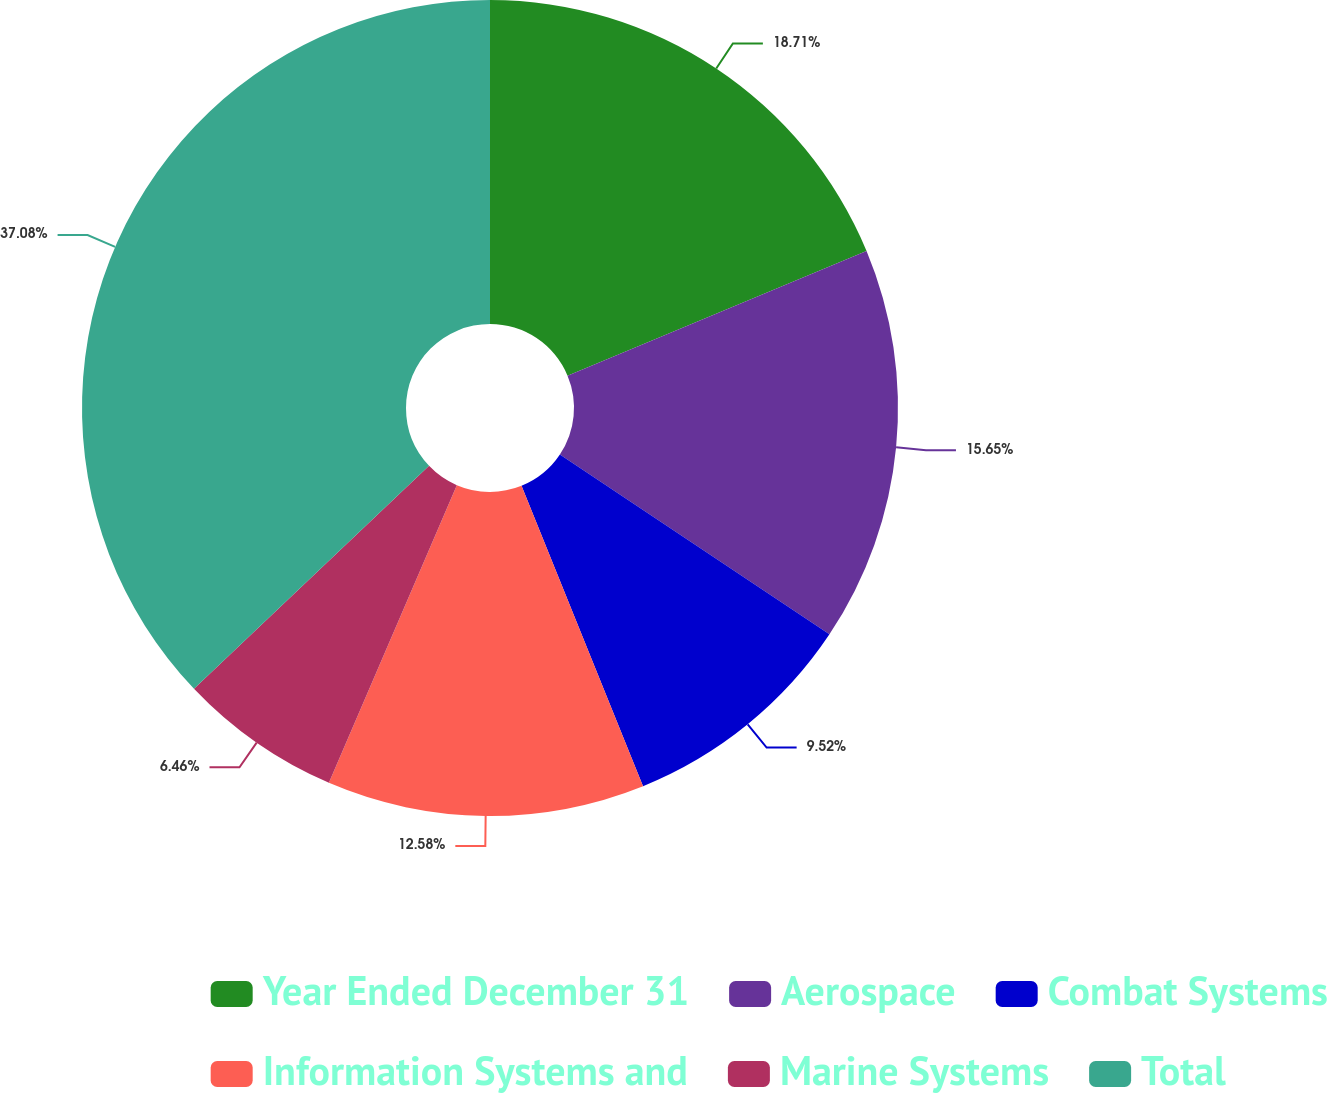Convert chart to OTSL. <chart><loc_0><loc_0><loc_500><loc_500><pie_chart><fcel>Year Ended December 31<fcel>Aerospace<fcel>Combat Systems<fcel>Information Systems and<fcel>Marine Systems<fcel>Total<nl><fcel>18.71%<fcel>15.65%<fcel>9.52%<fcel>12.58%<fcel>6.46%<fcel>37.08%<nl></chart> 